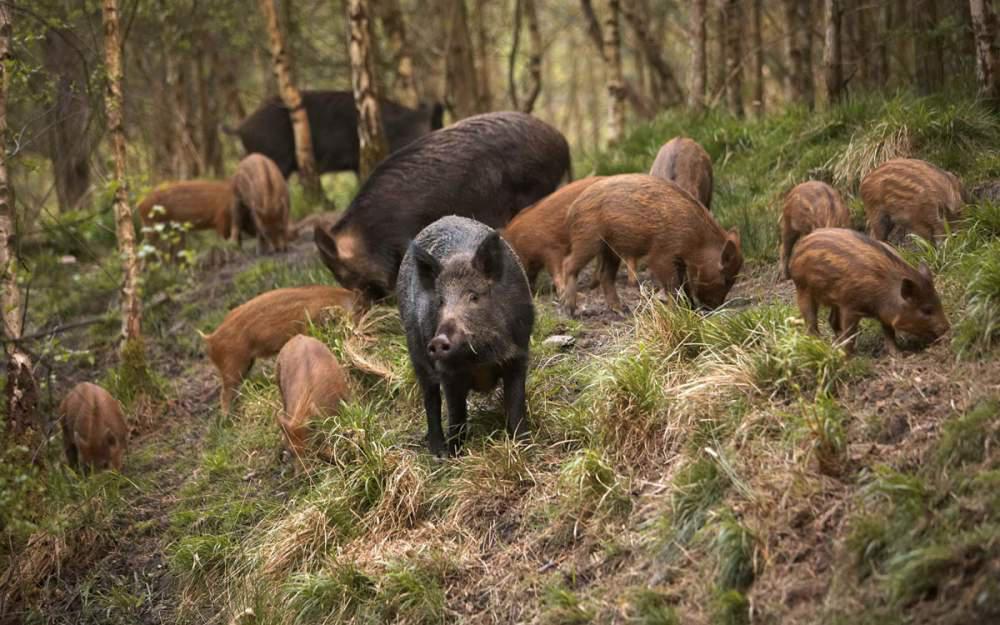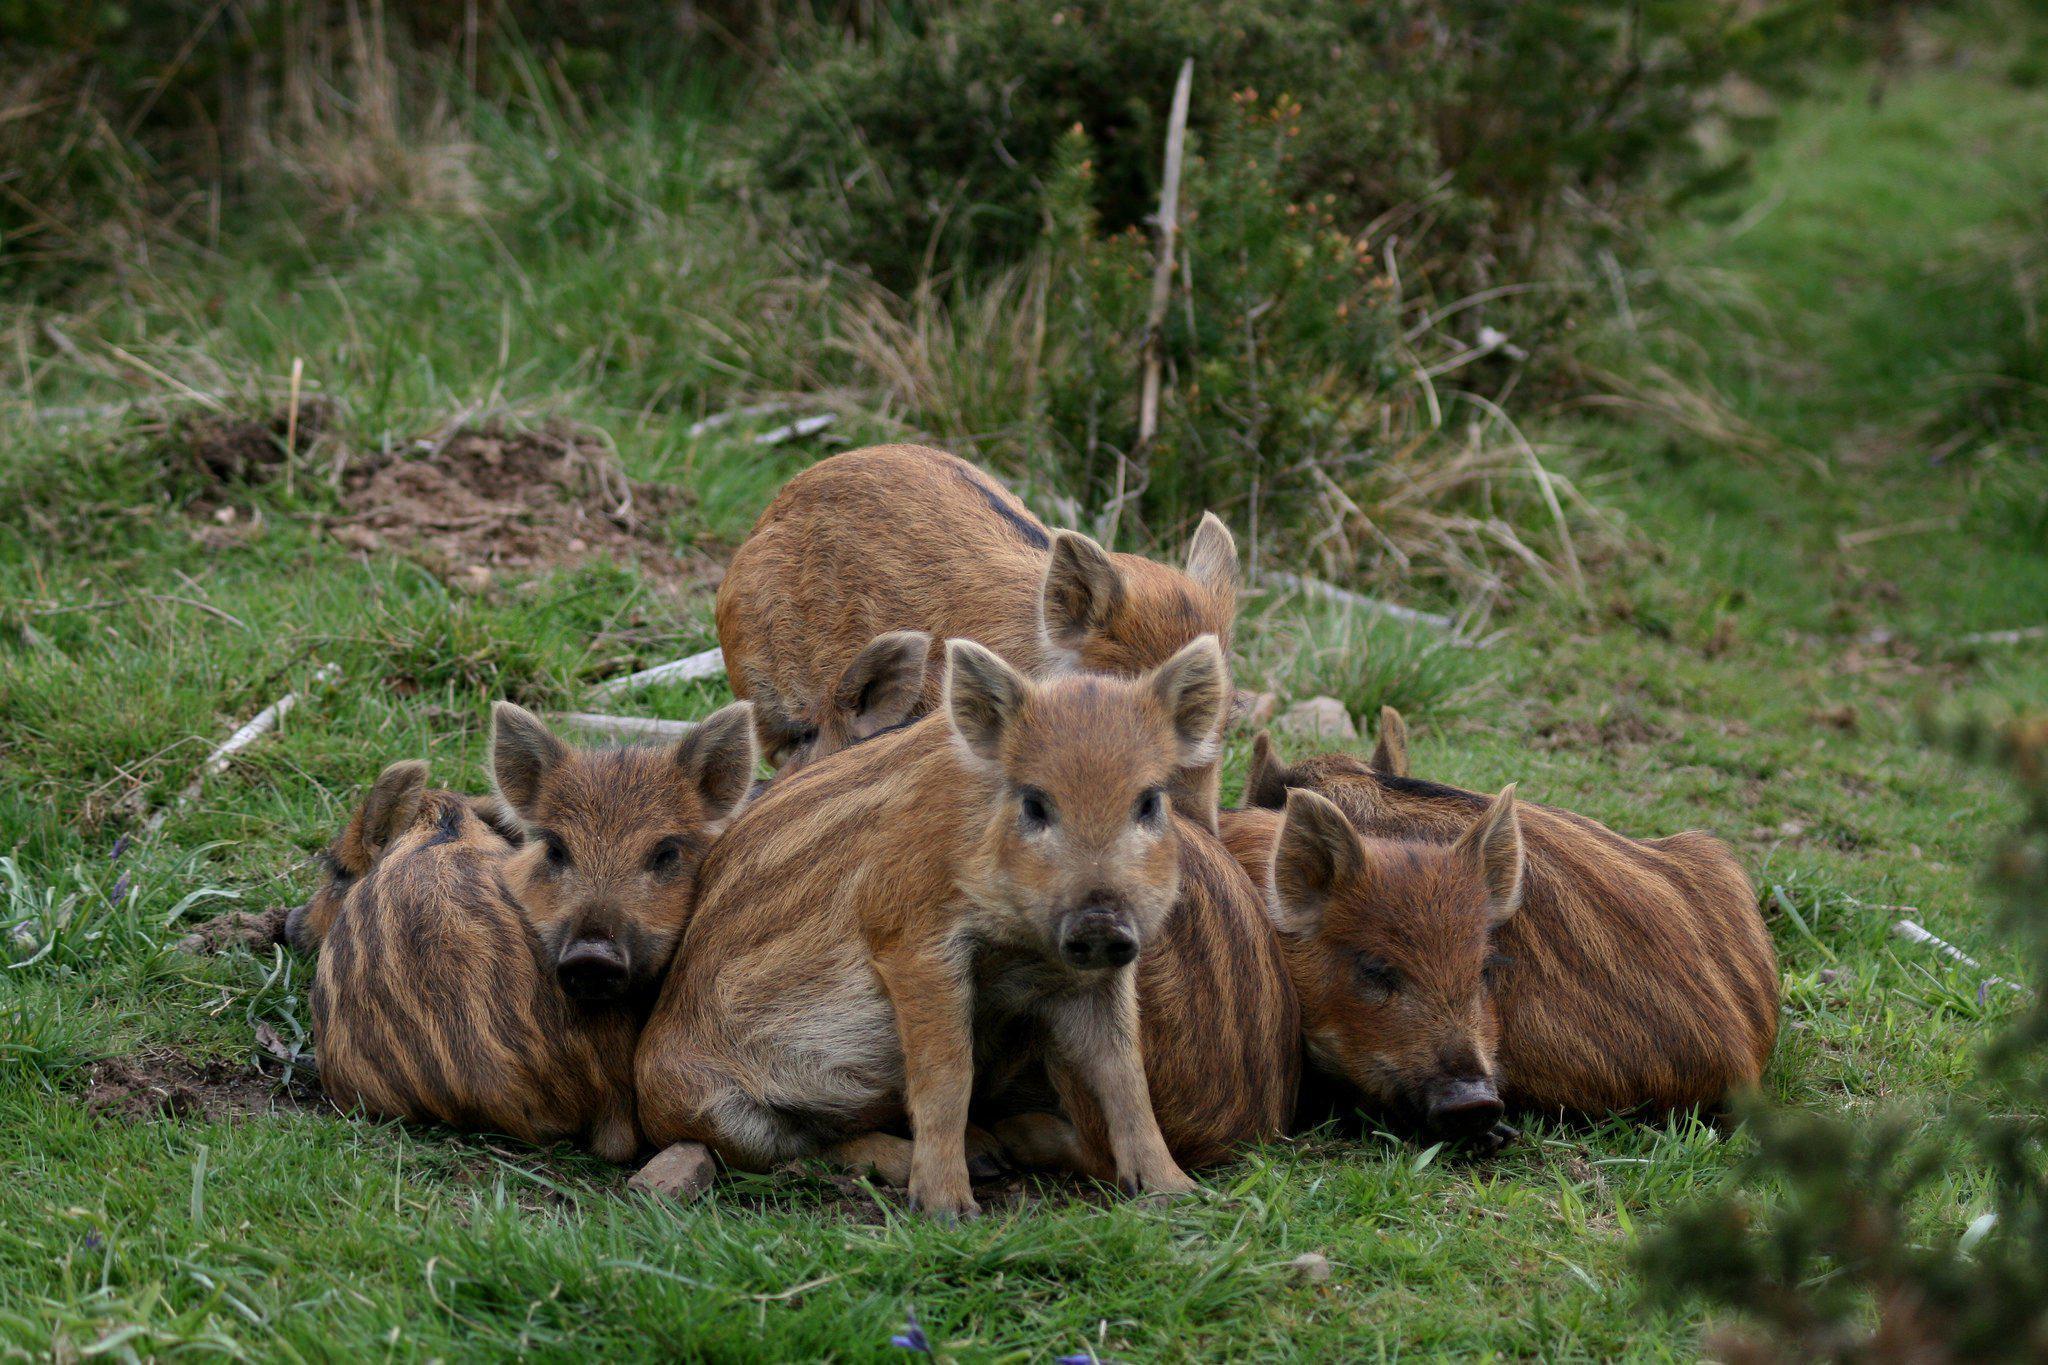The first image is the image on the left, the second image is the image on the right. For the images shown, is this caption "Each image contains exactly one wild pig, which is standing up and lacks distinctive stripes." true? Answer yes or no. No. The first image is the image on the left, the second image is the image on the right. Given the left and right images, does the statement "Exactly two living beings are in a forest." hold true? Answer yes or no. No. 